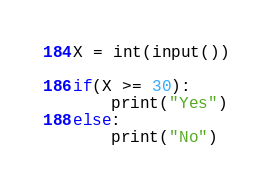Convert code to text. <code><loc_0><loc_0><loc_500><loc_500><_Python_>X = int(input())

if(X >= 30):
    print("Yes")
else:
    print("No")
</code> 